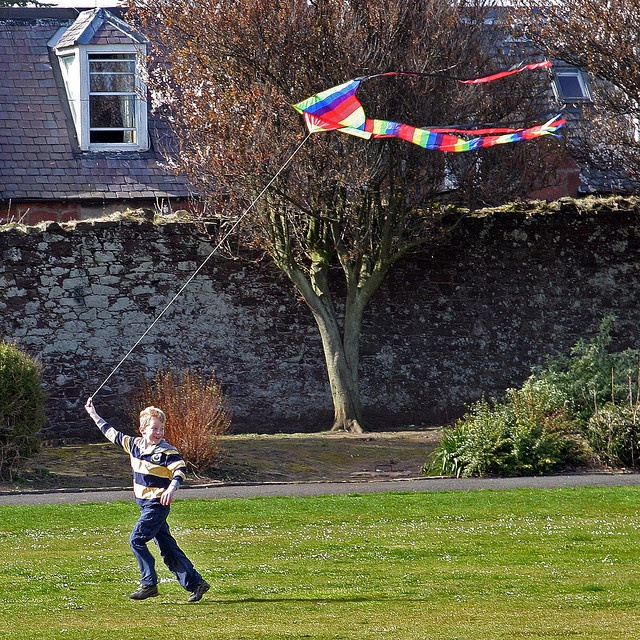Describe the objects in this image and their specific colors. I can see people in black, white, navy, and gray tones and kite in black, ivory, salmon, and red tones in this image. 